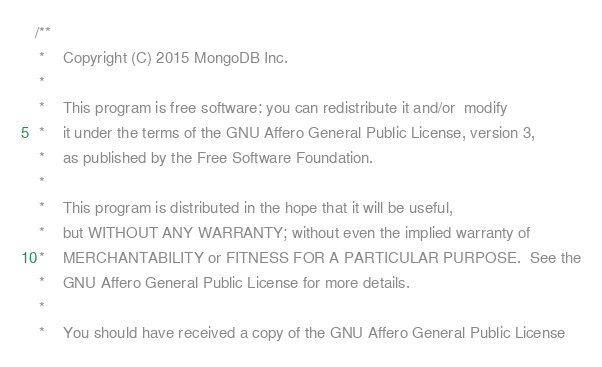Convert code to text. <code><loc_0><loc_0><loc_500><loc_500><_C++_>/**
 *    Copyright (C) 2015 MongoDB Inc.
 *
 *    This program is free software: you can redistribute it and/or  modify
 *    it under the terms of the GNU Affero General Public License, version 3,
 *    as published by the Free Software Foundation.
 *
 *    This program is distributed in the hope that it will be useful,
 *    but WITHOUT ANY WARRANTY; without even the implied warranty of
 *    MERCHANTABILITY or FITNESS FOR A PARTICULAR PURPOSE.  See the
 *    GNU Affero General Public License for more details.
 *
 *    You should have received a copy of the GNU Affero General Public License</code> 